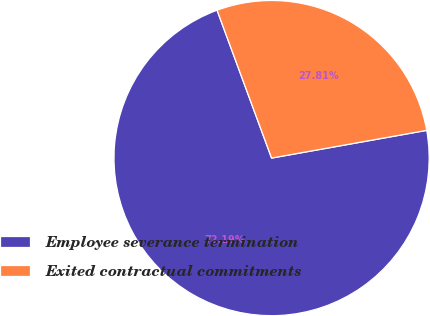<chart> <loc_0><loc_0><loc_500><loc_500><pie_chart><fcel>Employee severance termination<fcel>Exited contractual commitments<nl><fcel>72.19%<fcel>27.81%<nl></chart> 